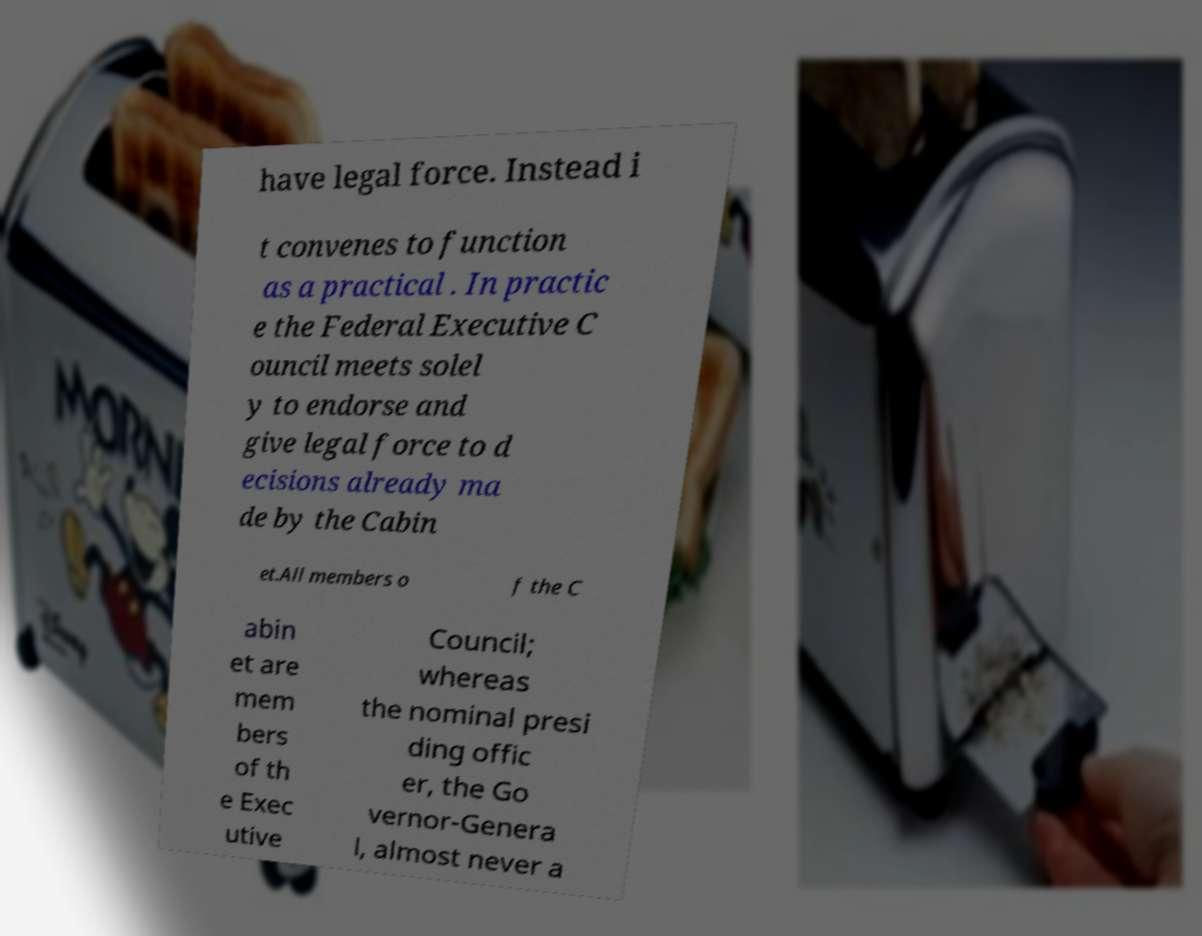For documentation purposes, I need the text within this image transcribed. Could you provide that? have legal force. Instead i t convenes to function as a practical . In practic e the Federal Executive C ouncil meets solel y to endorse and give legal force to d ecisions already ma de by the Cabin et.All members o f the C abin et are mem bers of th e Exec utive Council; whereas the nominal presi ding offic er, the Go vernor-Genera l, almost never a 